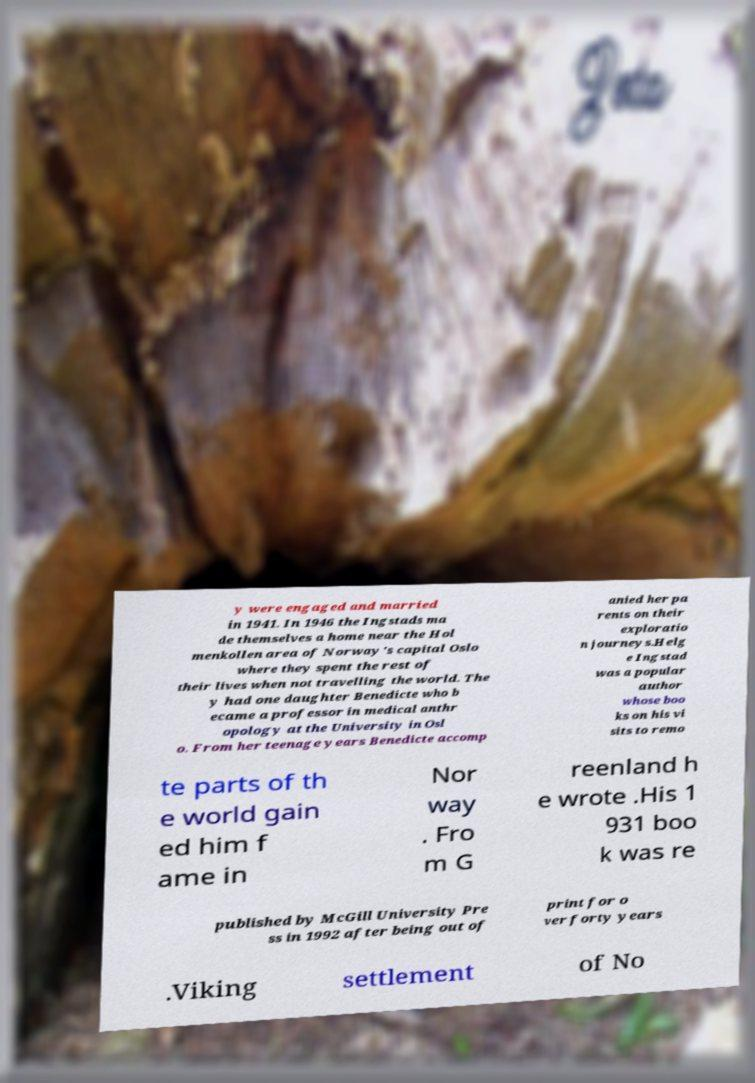Please read and relay the text visible in this image. What does it say? y were engaged and married in 1941. In 1946 the Ingstads ma de themselves a home near the Hol menkollen area of Norway's capital Oslo where they spent the rest of their lives when not travelling the world. The y had one daughter Benedicte who b ecame a professor in medical anthr opology at the University in Osl o. From her teenage years Benedicte accomp anied her pa rents on their exploratio n journeys.Helg e Ingstad was a popular author whose boo ks on his vi sits to remo te parts of th e world gain ed him f ame in Nor way . Fro m G reenland h e wrote .His 1 931 boo k was re published by McGill University Pre ss in 1992 after being out of print for o ver forty years .Viking settlement of No 